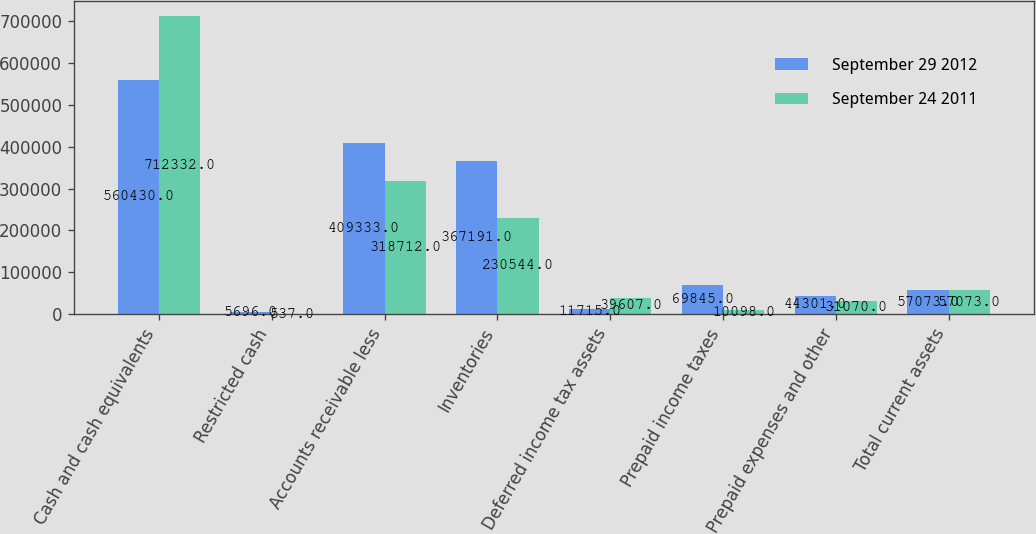Convert chart to OTSL. <chart><loc_0><loc_0><loc_500><loc_500><stacked_bar_chart><ecel><fcel>Cash and cash equivalents<fcel>Restricted cash<fcel>Accounts receivable less<fcel>Inventories<fcel>Deferred income tax assets<fcel>Prepaid income taxes<fcel>Prepaid expenses and other<fcel>Total current assets<nl><fcel>September 29 2012<fcel>560430<fcel>5696<fcel>409333<fcel>367191<fcel>11715<fcel>69845<fcel>44301<fcel>57073<nl><fcel>September 24 2011<fcel>712332<fcel>537<fcel>318712<fcel>230544<fcel>39607<fcel>10098<fcel>31070<fcel>57073<nl></chart> 